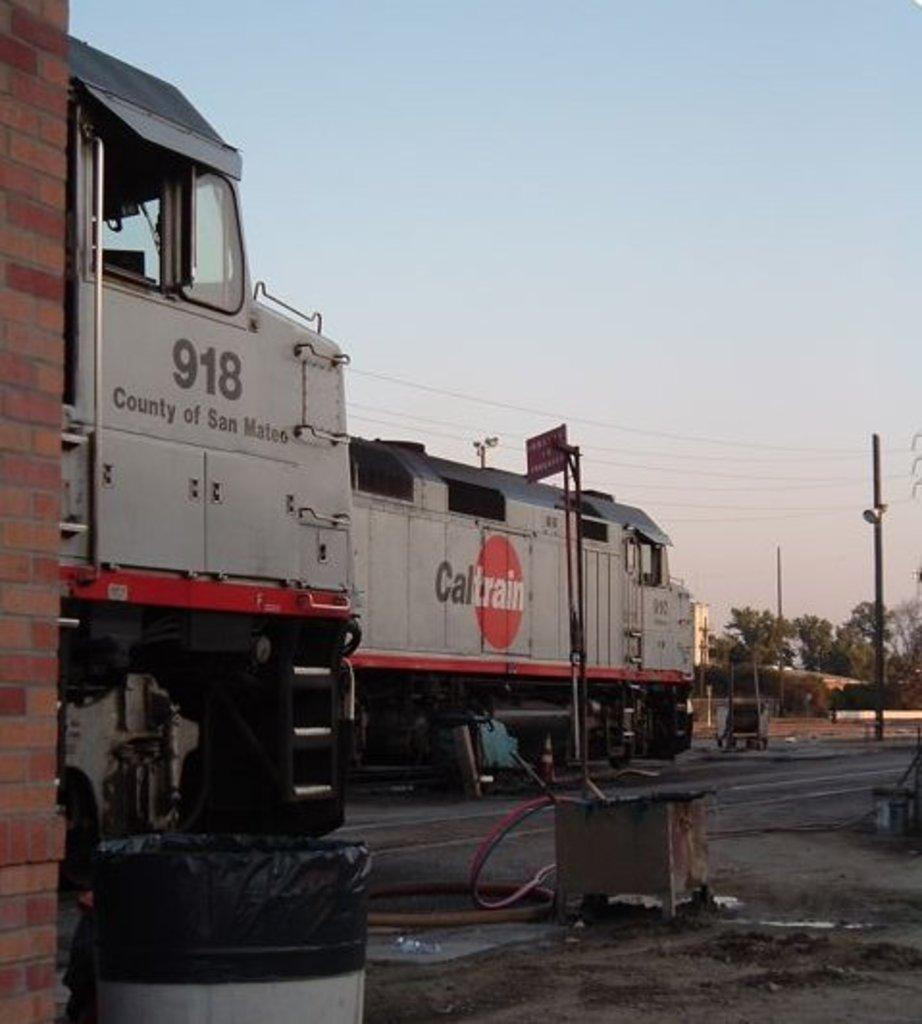What is the main object in the foreground of the image? There is a drum in the foreground of the image. What can be seen on the left side of the image? There is a wall on the left side of the image. How many trains are visible in the image? There are two trains in the image. What other structures can be seen in the image? There are poles in the image. What type of vegetation is present in the image? There are trees in the image. What else is present in the image besides the objects mentioned? There are cables in the image. What part of the natural environment is visible in the image? The sky is visible in the image. Can you tell me how many cans are stacked on the cow in the image? There is no cow or cans present in the image. 